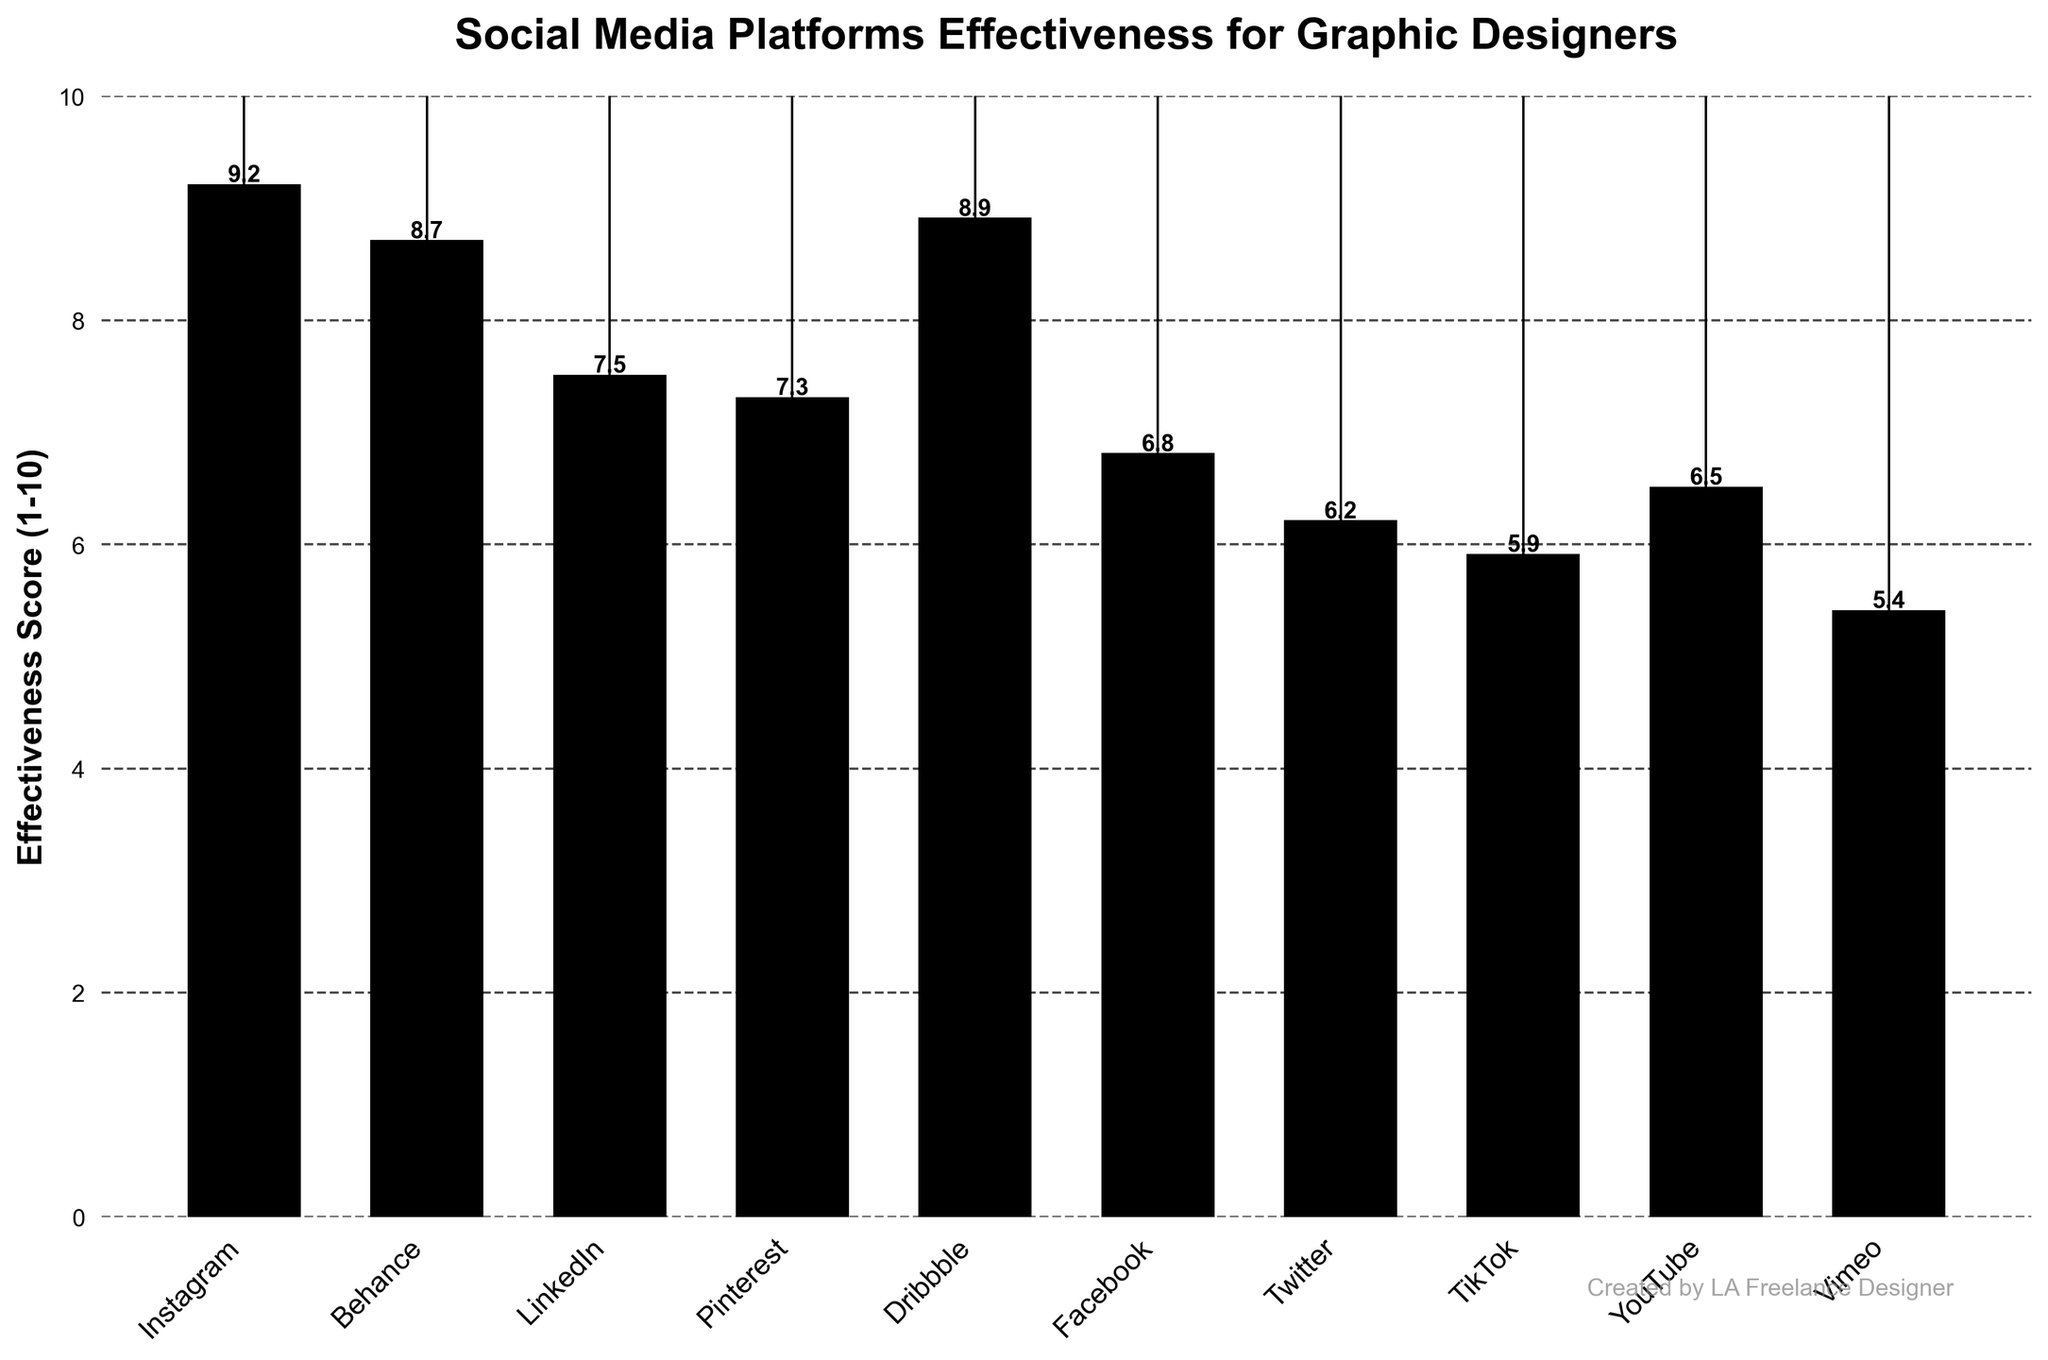What platform has the highest effectiveness score for graphic designers? The chart shows the effectiveness scores of various platforms. The bar representing Instagram reaches the highest value, which is 9.2.
Answer: Instagram Which platform ranks third in terms of effectiveness score? Reviewing the height of the bars in descending order, Instagram (9.2) ranks first, followed by Dribbble (8.9), and then Behance (8.7). Thus, Behance is the third-highest.
Answer: Behance How much more effective is Instagram compared to Pinterest? To find how much more effective Instagram is compared to Pinterest, subtract Pinterest's score from Instagram's score. Instagram has 9.2, and Pinterest has 7.3, so the difference is 9.2 - 7.3.
Answer: 1.9 Which platform has the lowest effectiveness score? The bar representing Vimeo is the shortest bar, with a value of 5.4, indicating it has the lowest score.
Answer: Vimeo What is the average effectiveness score for all platforms? Add all the effectiveness scores and then divide by the number of platforms. (9.2 + 8.7 + 7.5 + 7.3 + 8.9 + 6.8 + 6.2 + 5.9 + 6.5 + 5.4) / 10 = 7.24
Answer: 7.24 Which platform's score is closest to the average effectiveness score? The average effectiveness score is 7.24. By comparing this to each score, Twitter (6.2), Facebook (6.8), YouTube (6.5), and Pinterest (7.3) are close, with Pinterest being the closest at 7.3.
Answer: Pinterest How many platforms have an effectiveness score above 7.5? Count the bars with scores above 7.5. These include Instagram (9.2), Behance (8.7), Dribbble (8.9), and LinkedIn (7.5 is not above).
Answer: 3 What is the effectiveness score range among all platforms? The range is found by subtracting the lowest score from the highest score. Highest score is Instagram (9.2) and lowest is Vimeo (5.4). So, the range is 9.2 - 5.4.
Answer: 3.8 Which two platforms have the smallest difference in their effectiveness scores? Compare the difference between adjacent platforms or those with close values. LinkedIn (7.5) and Pinterest (7.3) have the smallest difference, which is 0.2.
Answer: LinkedIn and Pinterest 